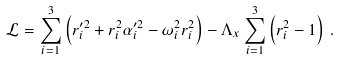Convert formula to latex. <formula><loc_0><loc_0><loc_500><loc_500>\mathcal { L } = \sum _ { i = 1 } ^ { 3 } \left ( r _ { i } ^ { \prime 2 } + r _ { i } ^ { 2 } \alpha _ { i } ^ { \prime 2 } - \omega _ { i } ^ { 2 } r _ { i } ^ { 2 } \right ) - \Lambda _ { x } \sum _ { i = 1 } ^ { 3 } \left ( r _ { i } ^ { 2 } - 1 \right ) \, .</formula> 